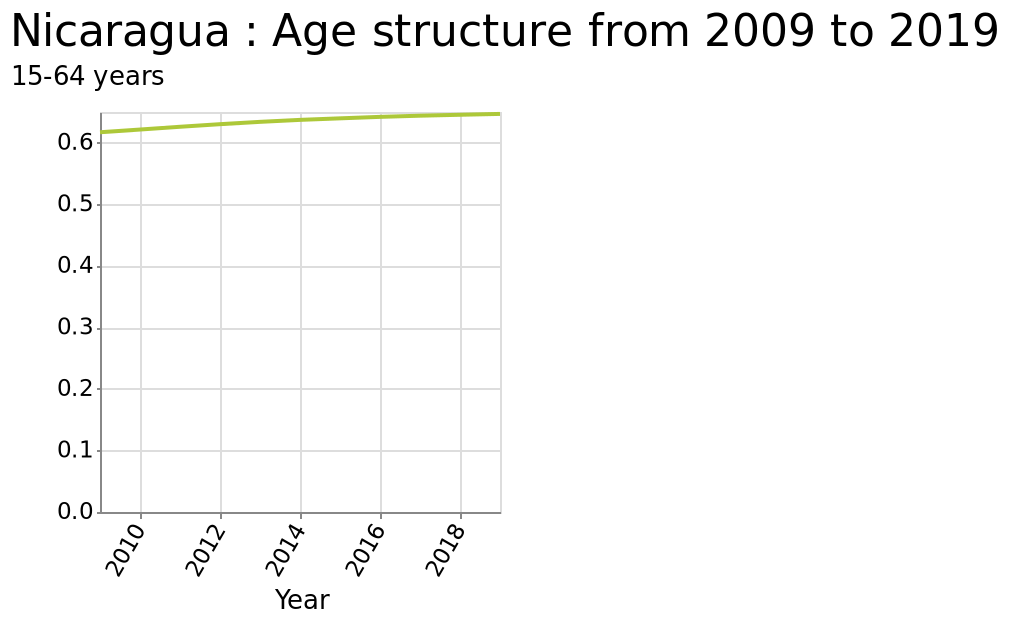<image>
How many years of data are represented in the line chart for Nicaragua's age structure? The line chart for Nicaragua's age structure represents data from 2009 to 2019, spanning a period of 11 years. 